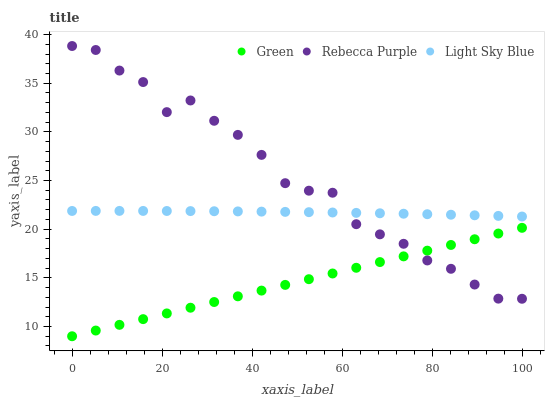Does Green have the minimum area under the curve?
Answer yes or no. Yes. Does Rebecca Purple have the maximum area under the curve?
Answer yes or no. Yes. Does Rebecca Purple have the minimum area under the curve?
Answer yes or no. No. Does Green have the maximum area under the curve?
Answer yes or no. No. Is Green the smoothest?
Answer yes or no. Yes. Is Rebecca Purple the roughest?
Answer yes or no. Yes. Is Rebecca Purple the smoothest?
Answer yes or no. No. Is Green the roughest?
Answer yes or no. No. Does Green have the lowest value?
Answer yes or no. Yes. Does Rebecca Purple have the lowest value?
Answer yes or no. No. Does Rebecca Purple have the highest value?
Answer yes or no. Yes. Does Green have the highest value?
Answer yes or no. No. Is Green less than Light Sky Blue?
Answer yes or no. Yes. Is Light Sky Blue greater than Green?
Answer yes or no. Yes. Does Rebecca Purple intersect Green?
Answer yes or no. Yes. Is Rebecca Purple less than Green?
Answer yes or no. No. Is Rebecca Purple greater than Green?
Answer yes or no. No. Does Green intersect Light Sky Blue?
Answer yes or no. No. 